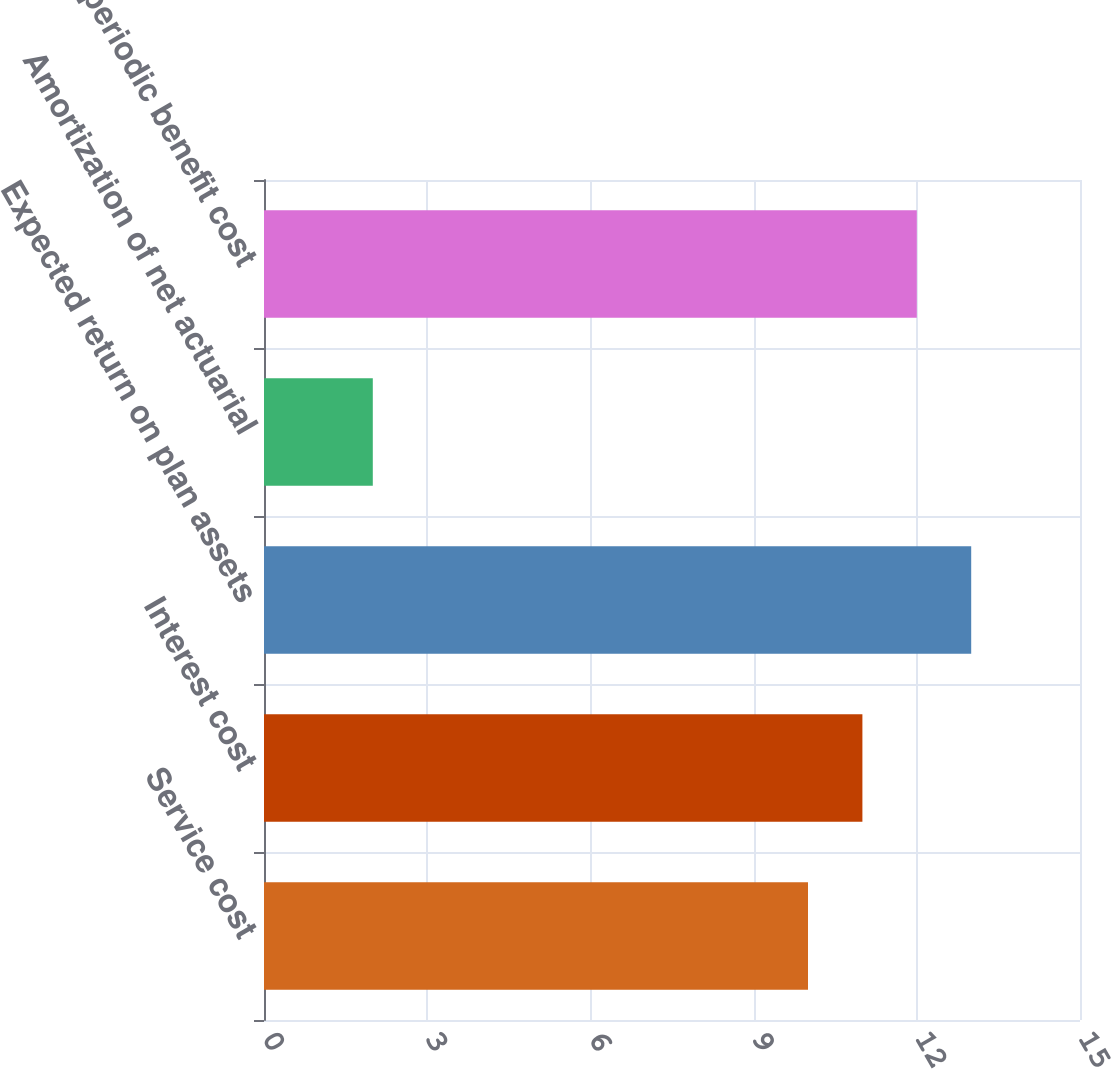Convert chart to OTSL. <chart><loc_0><loc_0><loc_500><loc_500><bar_chart><fcel>Service cost<fcel>Interest cost<fcel>Expected return on plan assets<fcel>Amortization of net actuarial<fcel>Net periodic benefit cost<nl><fcel>10<fcel>11<fcel>13<fcel>2<fcel>12<nl></chart> 